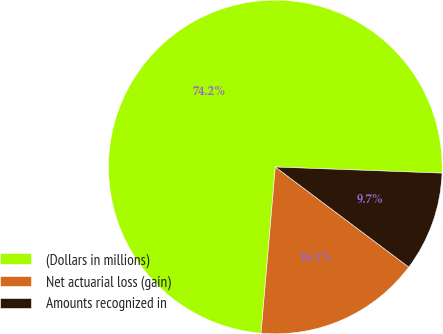Convert chart. <chart><loc_0><loc_0><loc_500><loc_500><pie_chart><fcel>(Dollars in millions)<fcel>Net actuarial loss (gain)<fcel>Amounts recognized in<nl><fcel>74.22%<fcel>16.12%<fcel>9.66%<nl></chart> 